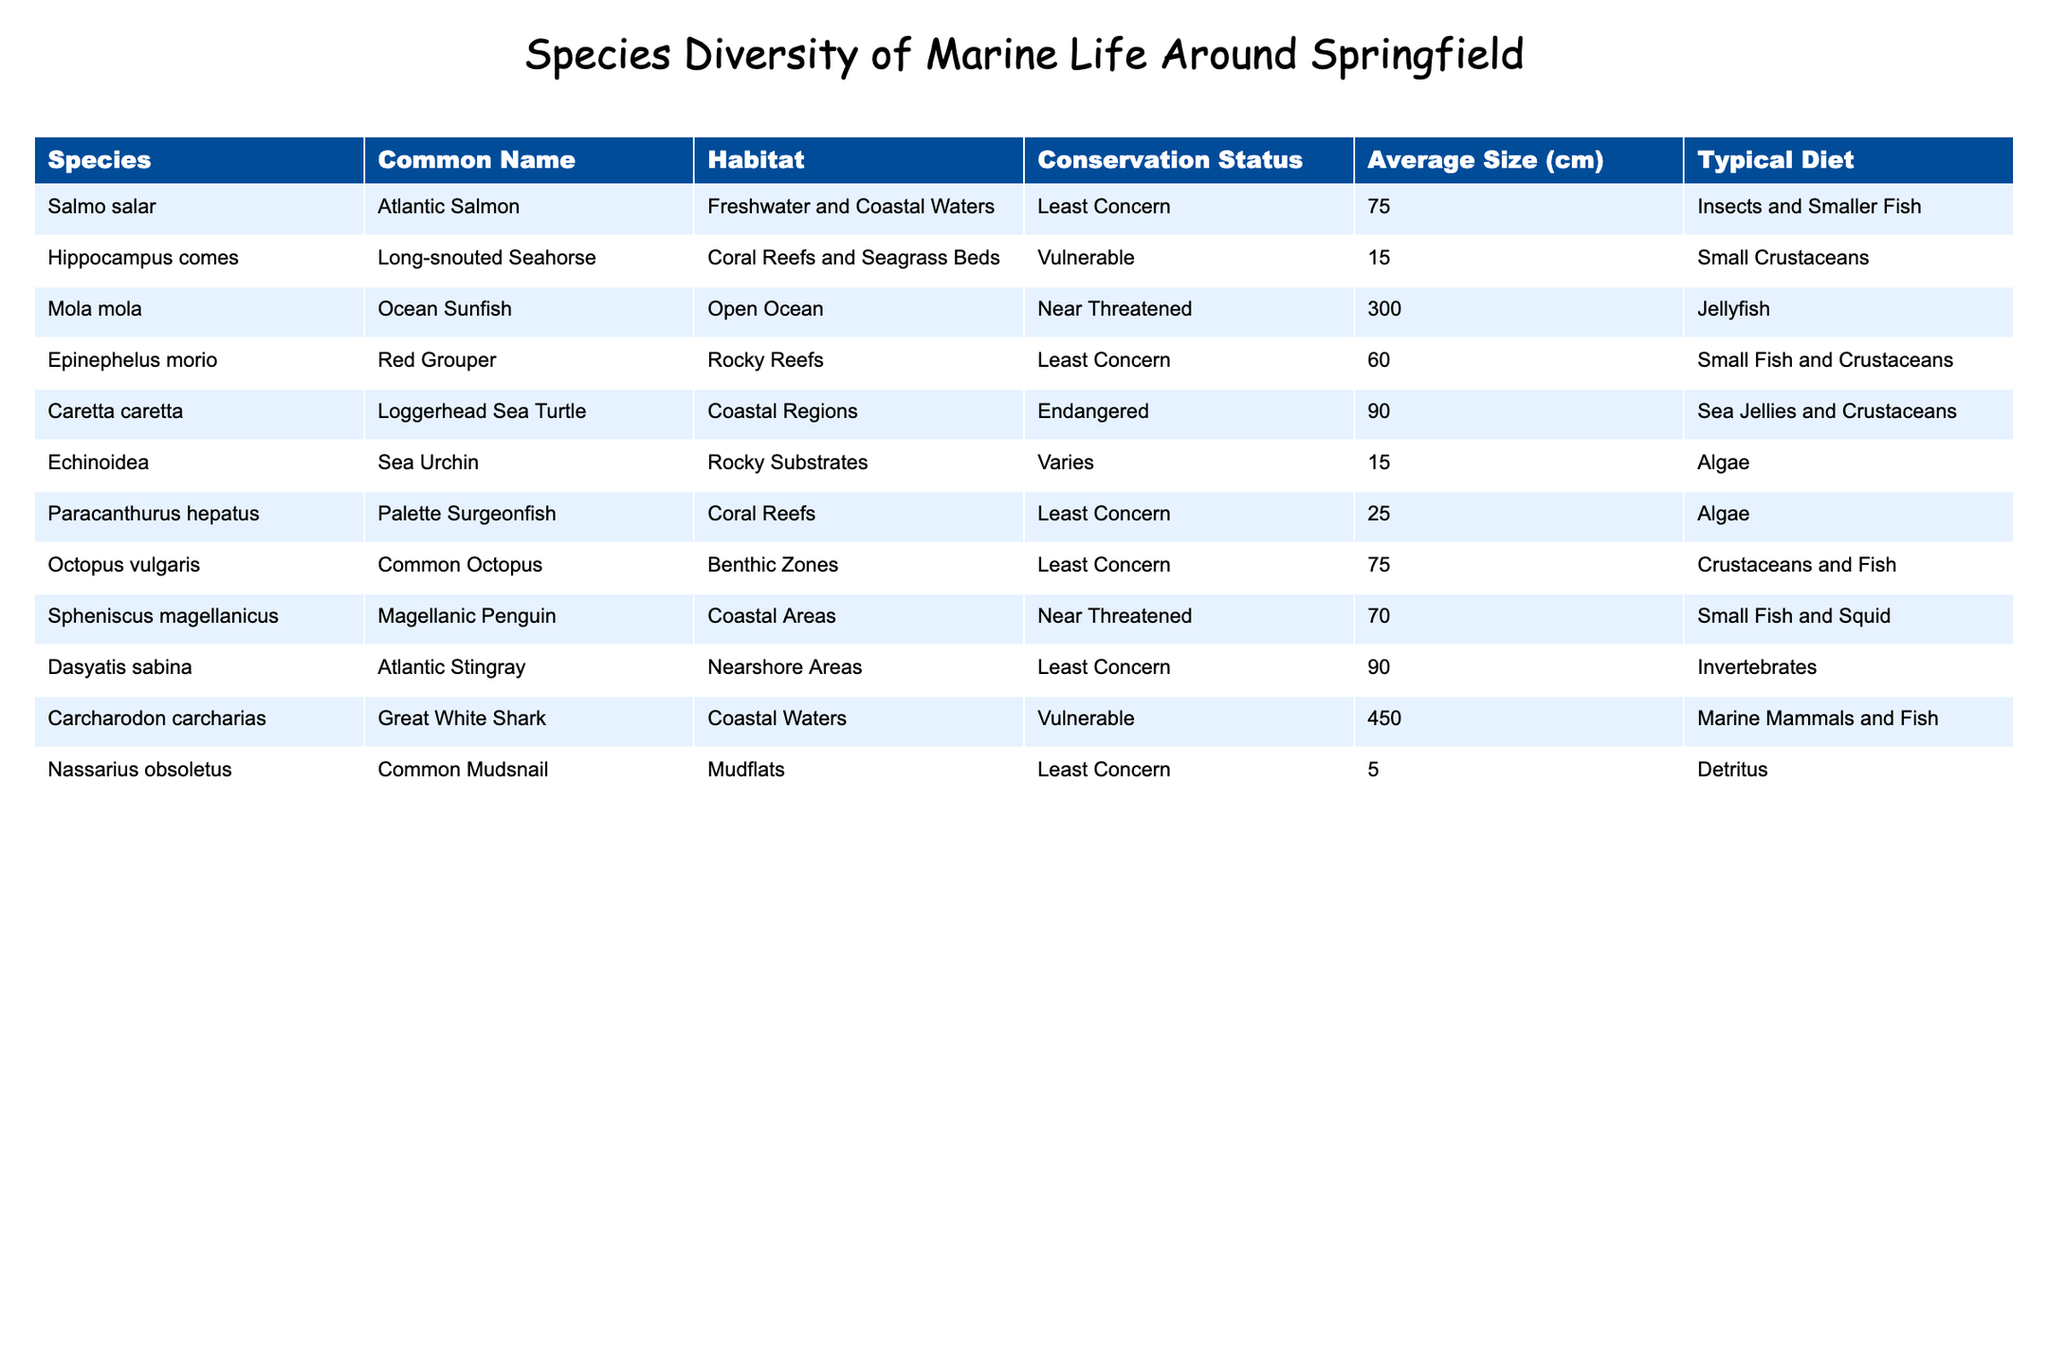What is the conservation status of the Loggerhead Sea Turtle? The Loggerhead Sea Turtle is listed in the table under "Conservation Status," where its status is marked as "Endangered."
Answer: Endangered Which species has the largest average size? Referring to the "Average Size (cm)" column, the Great White Shark has the largest average size at 450 cm.
Answer: 450 cm How many species have a conservation status of "Least Concern"? In the "Conservation Status" column, we can count the occurrences of "Least Concern." There are 5 species listed as "Least Concern."
Answer: 5 Is the Long-snouted Seahorse more at risk than the Ocean Sunfish? In the table, the status of the Long-snouted Seahorse is "Vulnerable," while the Ocean Sunfish is "Near Threatened." Since "Near Threatened" indicates a higher risk than "Vulnerable," the statement is false.
Answer: No What is the average size of all the species listed in the table? First, we need to sum the average sizes of each species: 75 + 15 + 300 + 60 + 90 + 15 + 25 + 75 + 70 + 90 + 450 + 5 = 1,195 cm. Then we divide by the number of species, which is 12, giving us an average of 1,195 / 12 = 99.58 cm.
Answer: 99.58 cm How many species listed inhabit coastal regions? Looking at the "Habitat" column, the species that inhabit coastal regions are: Loggerhead Sea Turtle, Great White Shark, and Atlantic Stingray. This sums up to 3 species.
Answer: 3 Which species typically feeds on invertebrates? In the "Typical Diet" column, the Atlantic Stingray is the species described as feeding on invertebrates.
Answer: Atlantic Stingray Is there any marine species in the table that has a typical diet of both fish and crustaceans? The Common Octopus feeds on crustaceans and fish, confirming that there is a species with that diet.
Answer: Yes What is the difference in average size between the Ocean Sunfish and the Atlantic Salmon? The average size of the Ocean Sunfish is 300 cm, while the Atlantic Salmon is 75 cm. The difference is 300 - 75 = 225 cm.
Answer: 225 cm Which species has the smallest average size and what is that size? In the "Average Size (cm)" column, the Common Mudsnail has the smallest size at 5 cm.
Answer: 5 cm 